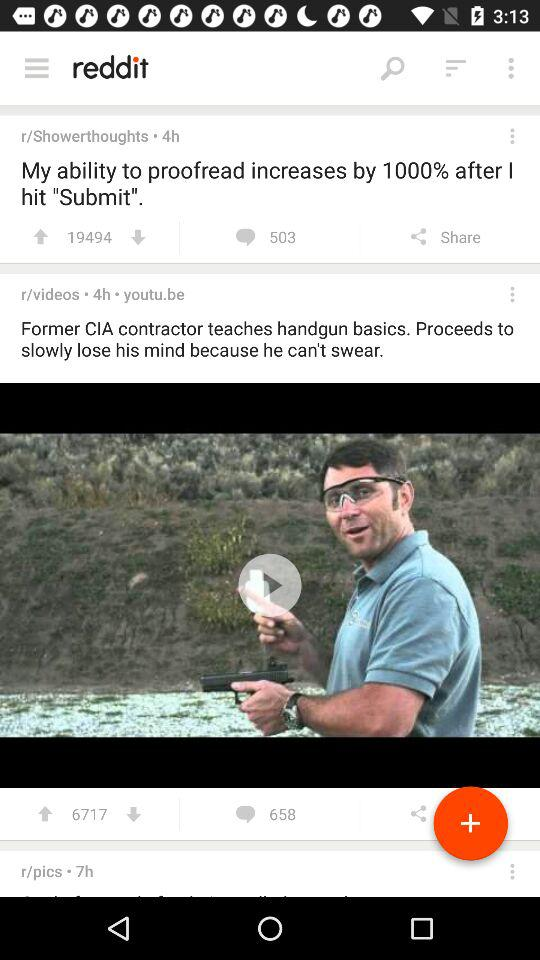Who shared the post?
When the provided information is insufficient, respond with <no answer>. <no answer> 